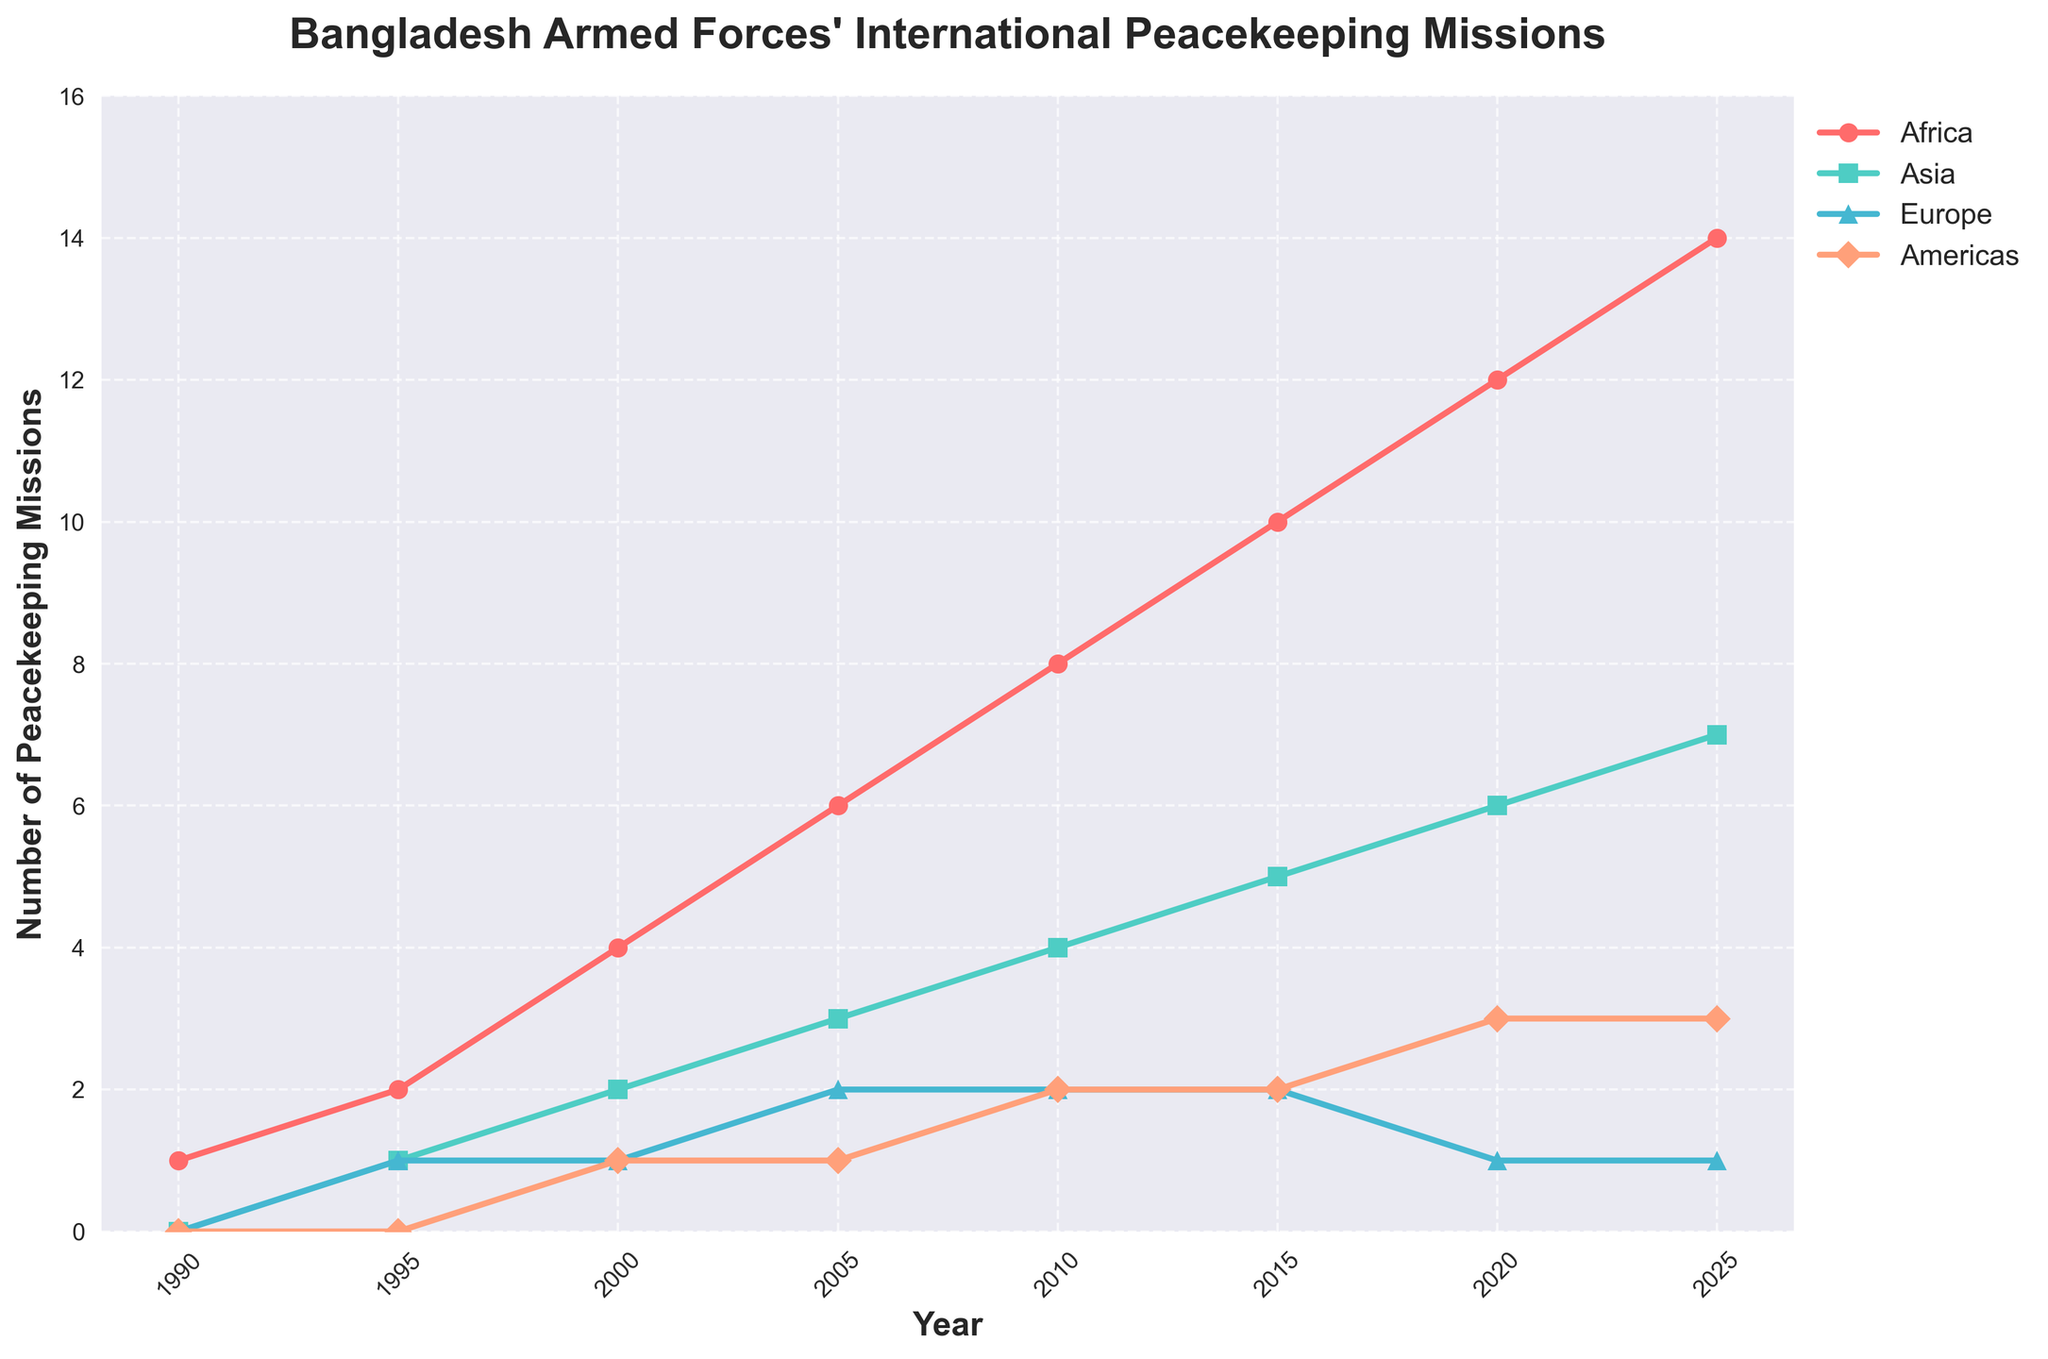what year did the Bangladesh Armed Forces participate in the most peacekeeping missions in Africa? The highest value in the Africa category is 14, which occurs in the year 2025. This is visually identified as the highest point on the red line.
Answer: 2025 Which continent had the least number of peacekeeping missions in 2015? In 2015, the values are 10 for Africa, 5 for Asia, 2 for Europe, and 2 for Americas. Both Europe and Americas have the minimum value of 2.
Answer: Europe and Americas What is the difference in the number of peacekeeping missions in Africa between 1990 and 2020? In 1990, Africa had 1 mission, and in 2020, it had 12 missions. The difference is calculated as 12 - 1.
Answer: 11 In which year did Asia surpass Europe in the number of peacekeeping missions? Comparing the values for Asia and Europe across years, Asia surpasses Europe in 2020 when Asia has 6 and Europe has 1 mission.
Answer: 2020 On average, how many peacekeeping missions per year did the Bangladesh Armed Forces participate in on the continent of Europe between 1990 and 2025? Total missions in Europe from 1990 to 2025 are 0 + 1 + 1 + 2 + 2 + 2 + 1 + 1 = 10 over 8 intervals (35 years). Since the average per year ought to be calculated by dividing the total by the number of intervals, the average is 10/8.
Answer: 1.25 How many more peacekeeping missions did Bangladesh Armed Forces participate in the Americas in 2025 compared to Asia in 1995? In 2025, Americas had 3 missions, and in 1995, Asia had 1 mission. The difference is 3 - 1.
Answer: 2 Which continent showed a consistent increase in peacekeeping missions from 1990 to 2025? Observing the trends for each continent, Africa consistently increases each five years period.
Answer: Africa In 2010, which continent(s) had an equal number of peacekeeping missions? In 2010, Europe and Asia both had 2 missions each.
Answer: Europe and Asia By how much did the number of peacekeeping missions in Asia increase from 1990 to 2025? In 1990, Asia had 0 missions, and in 2025, Asia had 7 missions. The increase is calculated as 7 - 0.
Answer: 7 